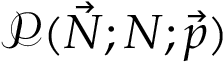Convert formula to latex. <formula><loc_0><loc_0><loc_500><loc_500>\mathcal { P } ( \vec { N } ; N ; \vec { p } )</formula> 